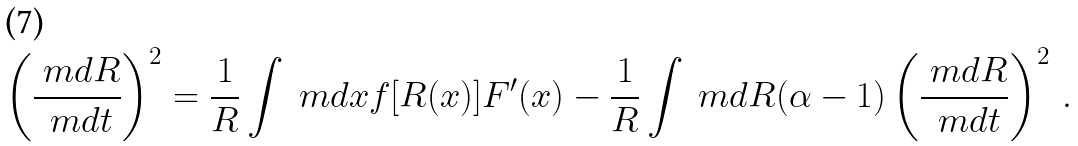Convert formula to latex. <formula><loc_0><loc_0><loc_500><loc_500>\left ( \frac { \ m d R } { \ m d t } \right ) ^ { 2 } = \frac { 1 } { R } \int \ m d x f [ R ( x ) ] F ^ { \prime } ( x ) - \frac { 1 } { R } \int \ m d R ( \alpha - 1 ) \left ( \frac { \ m d R } { \ m d t } \right ) ^ { 2 } \, .</formula> 